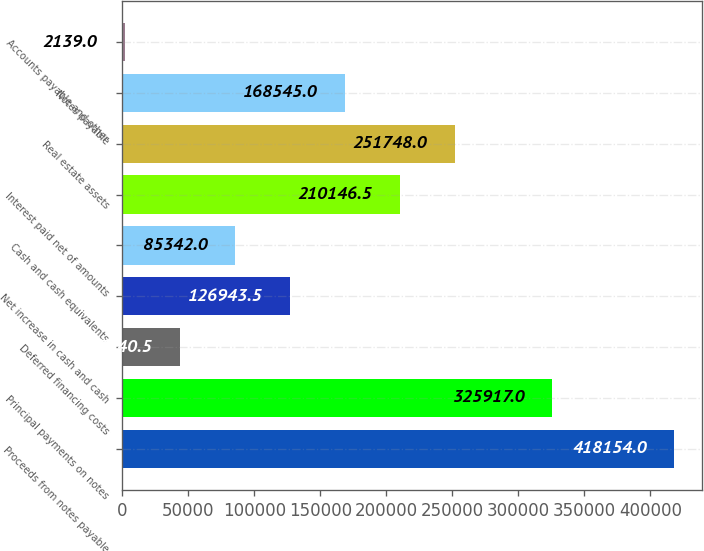Convert chart. <chart><loc_0><loc_0><loc_500><loc_500><bar_chart><fcel>Proceeds from notes payable<fcel>Principal payments on notes<fcel>Deferred financing costs<fcel>Net increase in cash and cash<fcel>Cash and cash equivalents<fcel>Interest paid net of amounts<fcel>Real estate assets<fcel>Notes payable<fcel>Accounts payable and other<nl><fcel>418154<fcel>325917<fcel>43740.5<fcel>126944<fcel>85342<fcel>210146<fcel>251748<fcel>168545<fcel>2139<nl></chart> 